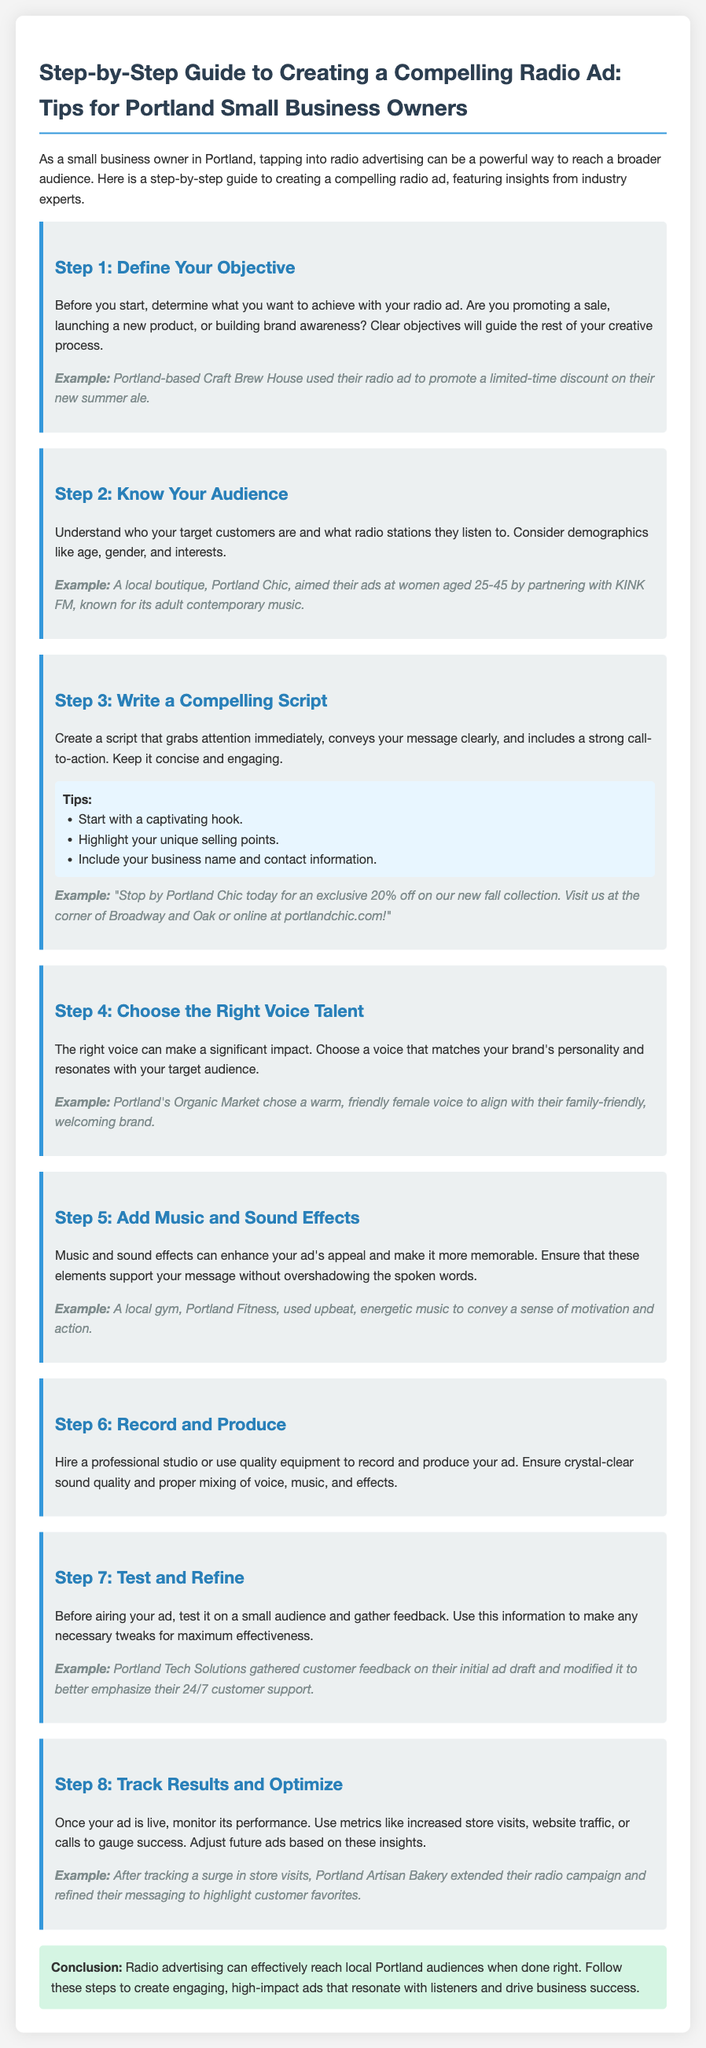What is the first step in creating a radio ad? The first step outlined in the document is to define your objective for the radio ad.
Answer: Define Your Objective What should you understand about your audience? It is important to know who your target customers are and what radio stations they listen to.
Answer: Target customers and radio stations What is an example of a call to action from the script? The document provides an example where Portland Chic encourages listeners to visit their store for a discount.
Answer: Exclusive 20% off What is Step 5 in creating a radio ad? Step 5 focuses on adding music and sound effects to enhance the ad's appeal.
Answer: Add Music and Sound Effects Who did Portland's Organic Market choose as their voice talent? They chose a warm, friendly female voice that aligned with their brand personality.
Answer: Warm, friendly female voice What should you do after your ad is live? You should track results and optimize based on the performance metrics collected.
Answer: Track Results and Optimize What is a specific tip for writing a compelling script? One tip mentioned is to start with a captivating hook.
Answer: Start with a captivating hook How can you test your radio ad before airing it? The document suggests testing it on a small audience and gathering feedback for refinement.
Answer: Test on a small audience What is the final step in the guide? The final step is to track results and optimize for future ads.
Answer: Track Results and Optimize What type of businesses does this guide target? The guide is specifically aimed at small business owners in Portland.
Answer: Small business owners in Portland 